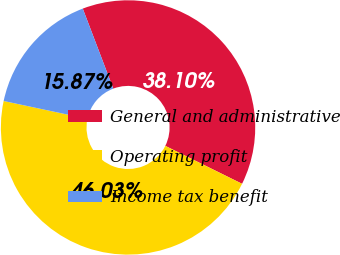<chart> <loc_0><loc_0><loc_500><loc_500><pie_chart><fcel>General and administrative<fcel>Operating profit<fcel>Income tax benefit<nl><fcel>38.1%<fcel>46.03%<fcel>15.87%<nl></chart> 